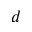Convert formula to latex. <formula><loc_0><loc_0><loc_500><loc_500>d</formula> 